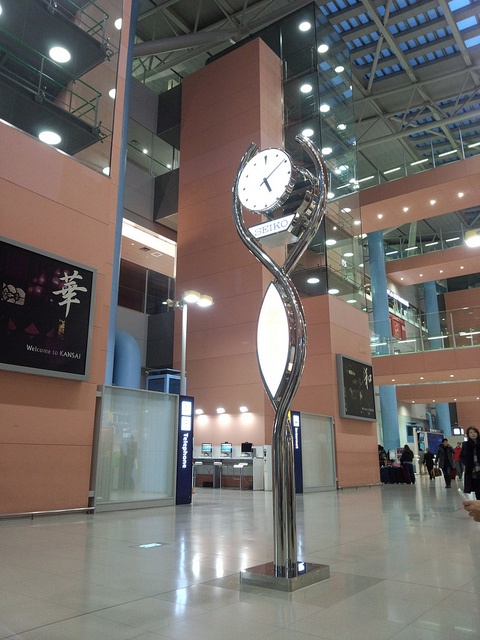Describe the objects in this image and their specific colors. I can see clock in gray, white, and darkgray tones, tv in gray, black, and darkgray tones, people in gray and black tones, people in gray, black, and maroon tones, and people in gray, black, and darkgray tones in this image. 